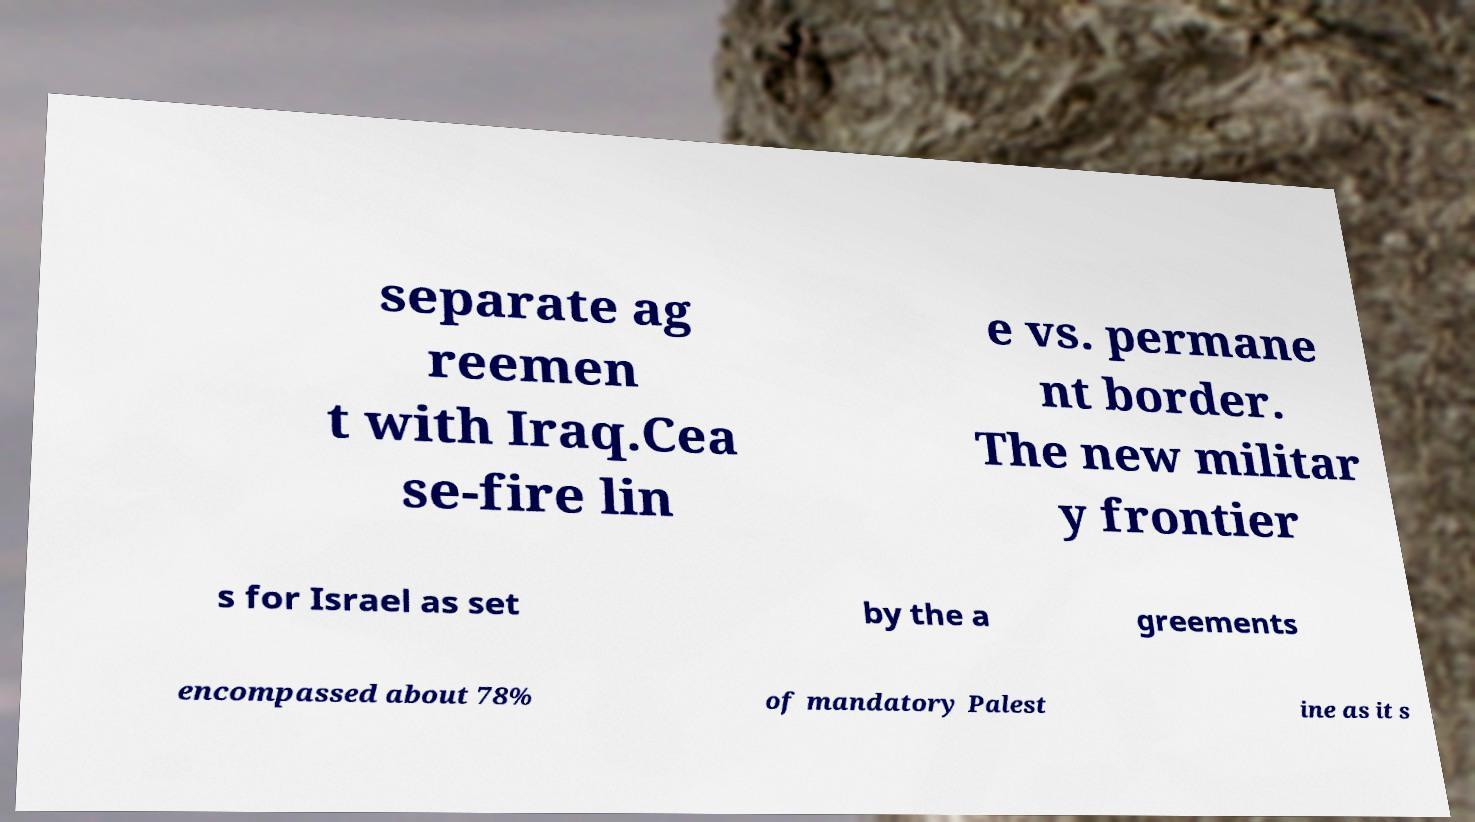Can you accurately transcribe the text from the provided image for me? separate ag reemen t with Iraq.Cea se-fire lin e vs. permane nt border. The new militar y frontier s for Israel as set by the a greements encompassed about 78% of mandatory Palest ine as it s 